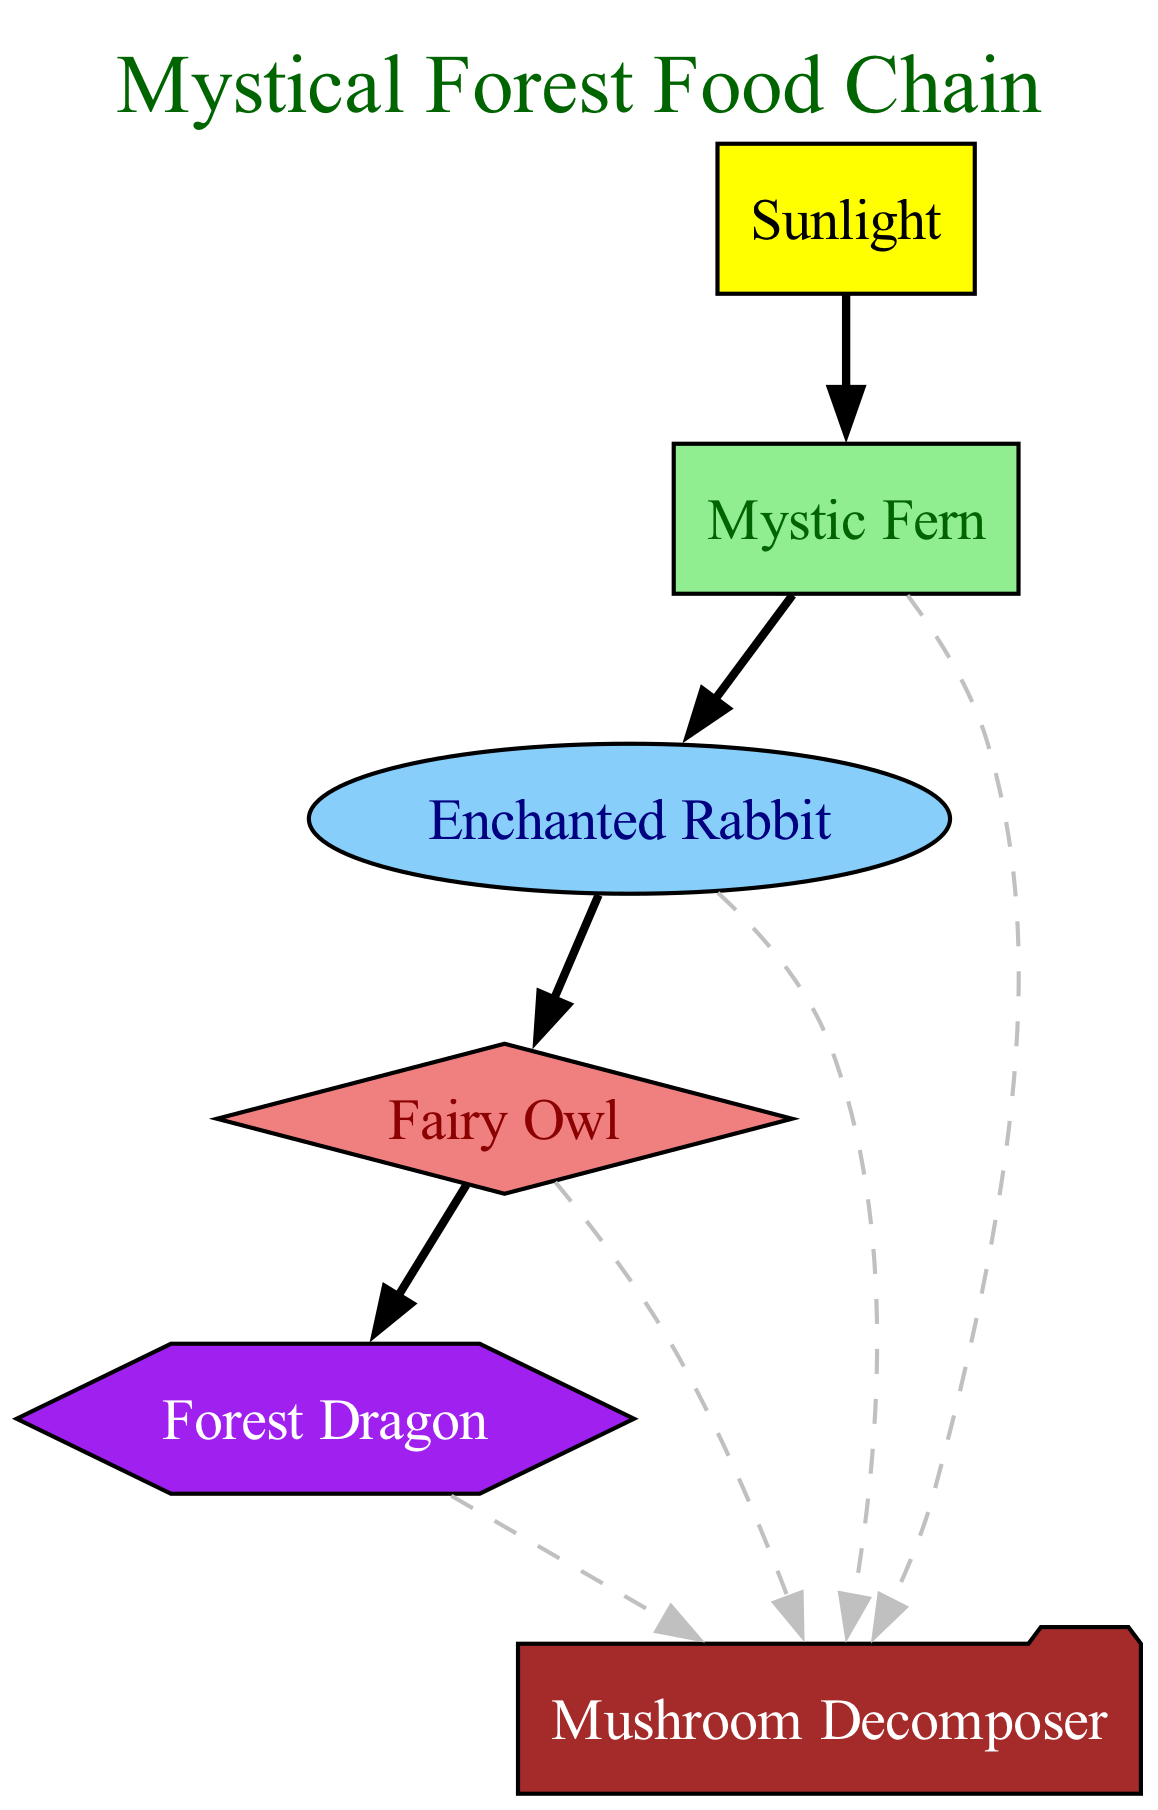What is the energy source of the food chain? The base of the food chain is labeled as "Sunlight," indicating that it is the primary energy source for all the elements that follow.
Answer: Sunlight Which organism is a primary consumer? The diagram lists "Enchanted Rabbit" as a primary consumer, which directly consumes the "Mystic Fern" (the producer) for energy.
Answer: Enchanted Rabbit How many producers are in the food chain? There is one producer in the diagram: "Mystic Fern," which takes energy from sunlight.
Answer: 1 What type of consumer is the Fairy Owl? By examining the diagram, it shows that "Fairy Owl" is connected to "Enchanted Rabbit" and is classified as a secondary consumer, indicating its role in the food chain.
Answer: Secondary consumer What organism does the Forest Dragon consume for energy? The connection indicates that "Forest Dragon" derives energy from the "Fairy Owl," which is the organism directly before it in the food chain.
Answer: Fairy Owl What is the role of the Mushroom Decomposer in the food chain? The "Mushroom Decomposer" is linked to all other organisms in the food chain by a dashed line, indicating it breaks down all organic material, returning nutrients to the ecosystem.
Answer: Decomposer How many total elements, including the base, are represented in the food chain? Counting all the listed organisms and the energy source "Sunlight," there are six elements shown in the diagram: one base and five elements.
Answer: 6 What type of organism consumes the Mystic Fern? The "Enchanted Rabbit" is designated as the primary consumer, which means it consumes the "Mystic Fern" for energy.
Answer: Primary consumer How does energy flow from the Mystic Fern to the Fairy Owl? The energy flows from "Mystic Fern" (the producer) to "Enchanted Rabbit" (the primary consumer), and then from "Enchanted Rabbit" to "Fairy Owl," indicating a direct energy transfer from one organism to the next.
Answer: Enchanted Rabbit 